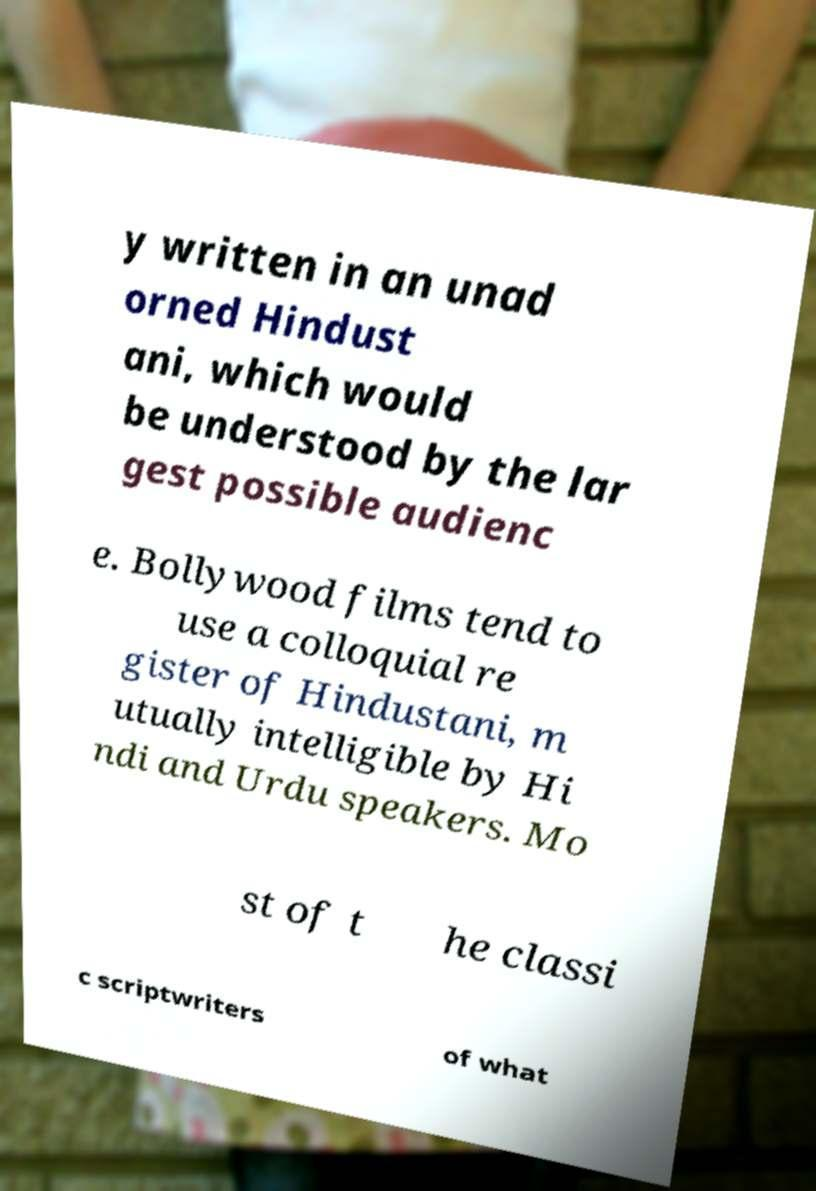Could you assist in decoding the text presented in this image and type it out clearly? y written in an unad orned Hindust ani, which would be understood by the lar gest possible audienc e. Bollywood films tend to use a colloquial re gister of Hindustani, m utually intelligible by Hi ndi and Urdu speakers. Mo st of t he classi c scriptwriters of what 